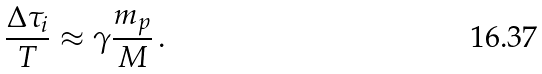<formula> <loc_0><loc_0><loc_500><loc_500>\frac { \Delta \tau _ { i } } { T } \approx \gamma \frac { m _ { p } } { M } \, .</formula> 